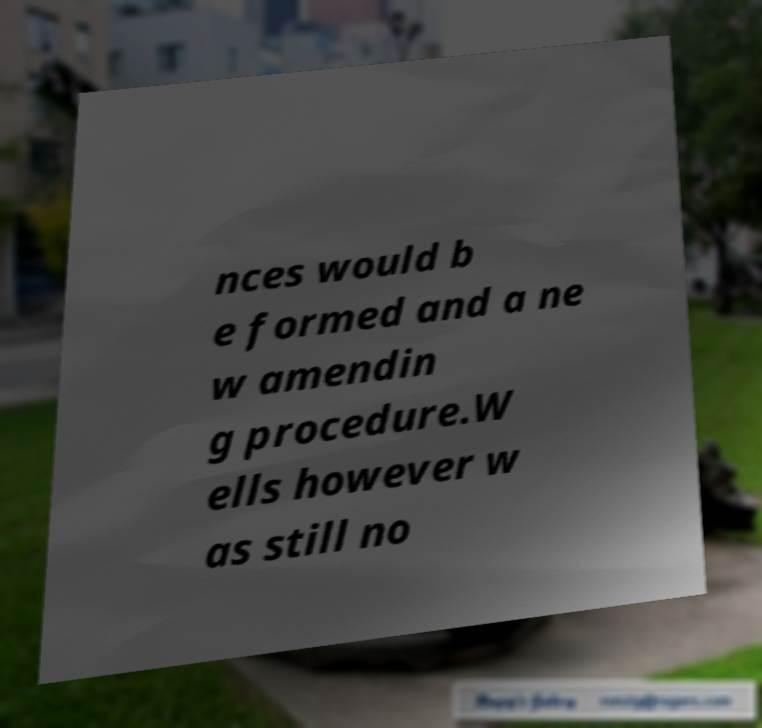Please read and relay the text visible in this image. What does it say? nces would b e formed and a ne w amendin g procedure.W ells however w as still no 